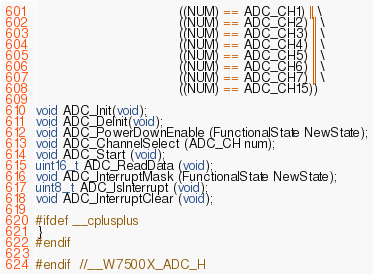Convert code to text. <code><loc_0><loc_0><loc_500><loc_500><_C_>		                           ((NUM) == ADC_CH1) || \
		                           ((NUM) == ADC_CH2) || \
		                           ((NUM) == ADC_CH3) || \
		                           ((NUM) == ADC_CH4) || \
		                           ((NUM) == ADC_CH5) || \
		                           ((NUM) == ADC_CH6) || \
		                           ((NUM) == ADC_CH7) || \
		                           ((NUM) == ADC_CH15))

void ADC_Init(void); 
void ADC_DeInit(void);
void ADC_PowerDownEnable (FunctionalState NewState);
void ADC_ChannelSelect (ADC_CH num);
void ADC_Start (void);
uint16_t ADC_ReadData (void);
void ADC_InterruptMask (FunctionalState NewState);
uint8_t ADC_IsInterrupt (void);
void ADC_InterruptClear (void);

#ifdef __cplusplus
 }
#endif

#endif  //__W7500X_ADC_H
</code> 